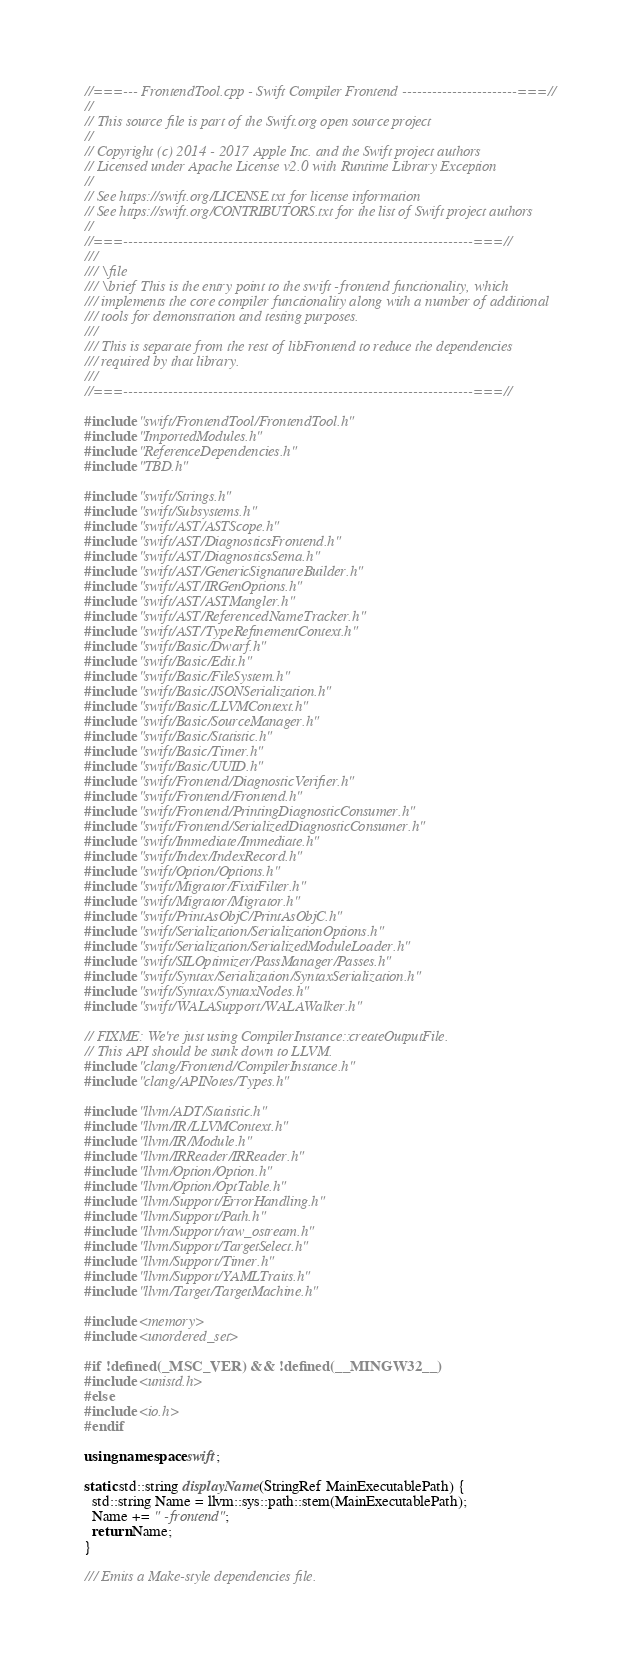<code> <loc_0><loc_0><loc_500><loc_500><_C++_>//===--- FrontendTool.cpp - Swift Compiler Frontend -----------------------===//
//
// This source file is part of the Swift.org open source project
//
// Copyright (c) 2014 - 2017 Apple Inc. and the Swift project authors
// Licensed under Apache License v2.0 with Runtime Library Exception
//
// See https://swift.org/LICENSE.txt for license information
// See https://swift.org/CONTRIBUTORS.txt for the list of Swift project authors
//
//===----------------------------------------------------------------------===//
///
/// \file
/// \brief This is the entry point to the swift -frontend functionality, which
/// implements the core compiler functionality along with a number of additional
/// tools for demonstration and testing purposes.
///
/// This is separate from the rest of libFrontend to reduce the dependencies
/// required by that library.
///
//===----------------------------------------------------------------------===//

#include "swift/FrontendTool/FrontendTool.h"
#include "ImportedModules.h"
#include "ReferenceDependencies.h"
#include "TBD.h"

#include "swift/Strings.h"
#include "swift/Subsystems.h"
#include "swift/AST/ASTScope.h"
#include "swift/AST/DiagnosticsFrontend.h"
#include "swift/AST/DiagnosticsSema.h"
#include "swift/AST/GenericSignatureBuilder.h"
#include "swift/AST/IRGenOptions.h"
#include "swift/AST/ASTMangler.h"
#include "swift/AST/ReferencedNameTracker.h"
#include "swift/AST/TypeRefinementContext.h"
#include "swift/Basic/Dwarf.h"
#include "swift/Basic/Edit.h"
#include "swift/Basic/FileSystem.h"
#include "swift/Basic/JSONSerialization.h"
#include "swift/Basic/LLVMContext.h"
#include "swift/Basic/SourceManager.h"
#include "swift/Basic/Statistic.h"
#include "swift/Basic/Timer.h"
#include "swift/Basic/UUID.h"
#include "swift/Frontend/DiagnosticVerifier.h"
#include "swift/Frontend/Frontend.h"
#include "swift/Frontend/PrintingDiagnosticConsumer.h"
#include "swift/Frontend/SerializedDiagnosticConsumer.h"
#include "swift/Immediate/Immediate.h"
#include "swift/Index/IndexRecord.h"
#include "swift/Option/Options.h"
#include "swift/Migrator/FixitFilter.h"
#include "swift/Migrator/Migrator.h"
#include "swift/PrintAsObjC/PrintAsObjC.h"
#include "swift/Serialization/SerializationOptions.h"
#include "swift/Serialization/SerializedModuleLoader.h"
#include "swift/SILOptimizer/PassManager/Passes.h"
#include "swift/Syntax/Serialization/SyntaxSerialization.h"
#include "swift/Syntax/SyntaxNodes.h"
#include "swift/WALASupport/WALAWalker.h"

// FIXME: We're just using CompilerInstance::createOutputFile.
// This API should be sunk down to LLVM.
#include "clang/Frontend/CompilerInstance.h"
#include "clang/APINotes/Types.h"

#include "llvm/ADT/Statistic.h"
#include "llvm/IR/LLVMContext.h"
#include "llvm/IR/Module.h"
#include "llvm/IRReader/IRReader.h"
#include "llvm/Option/Option.h"
#include "llvm/Option/OptTable.h"
#include "llvm/Support/ErrorHandling.h"
#include "llvm/Support/Path.h"
#include "llvm/Support/raw_ostream.h"
#include "llvm/Support/TargetSelect.h"
#include "llvm/Support/Timer.h"
#include "llvm/Support/YAMLTraits.h"
#include "llvm/Target/TargetMachine.h"

#include <memory>
#include <unordered_set>

#if !defined(_MSC_VER) && !defined(__MINGW32__)
#include <unistd.h>
#else
#include <io.h>
#endif

using namespace swift;

static std::string displayName(StringRef MainExecutablePath) {
  std::string Name = llvm::sys::path::stem(MainExecutablePath);
  Name += " -frontend";
  return Name;
}

/// Emits a Make-style dependencies file.</code> 